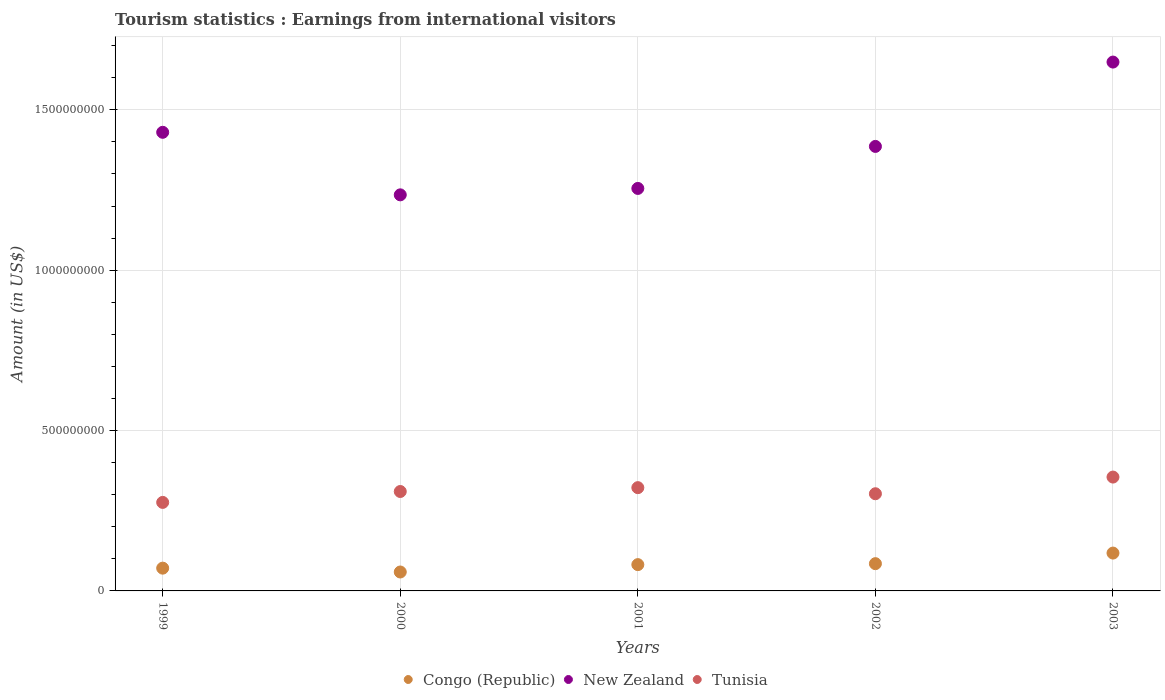Is the number of dotlines equal to the number of legend labels?
Make the answer very short. Yes. What is the earnings from international visitors in Tunisia in 2002?
Keep it short and to the point. 3.03e+08. Across all years, what is the maximum earnings from international visitors in Tunisia?
Offer a terse response. 3.55e+08. Across all years, what is the minimum earnings from international visitors in Congo (Republic)?
Your answer should be compact. 5.90e+07. In which year was the earnings from international visitors in New Zealand maximum?
Your answer should be compact. 2003. In which year was the earnings from international visitors in Tunisia minimum?
Your answer should be compact. 1999. What is the total earnings from international visitors in Congo (Republic) in the graph?
Provide a short and direct response. 4.15e+08. What is the difference between the earnings from international visitors in New Zealand in 1999 and that in 2001?
Ensure brevity in your answer.  1.75e+08. What is the difference between the earnings from international visitors in Congo (Republic) in 2003 and the earnings from international visitors in New Zealand in 2000?
Your answer should be compact. -1.12e+09. What is the average earnings from international visitors in Congo (Republic) per year?
Provide a short and direct response. 8.30e+07. In the year 2001, what is the difference between the earnings from international visitors in Congo (Republic) and earnings from international visitors in New Zealand?
Your answer should be compact. -1.17e+09. What is the ratio of the earnings from international visitors in New Zealand in 1999 to that in 2003?
Offer a terse response. 0.87. Is the difference between the earnings from international visitors in Congo (Republic) in 1999 and 2000 greater than the difference between the earnings from international visitors in New Zealand in 1999 and 2000?
Your answer should be compact. No. What is the difference between the highest and the second highest earnings from international visitors in New Zealand?
Provide a short and direct response. 2.19e+08. What is the difference between the highest and the lowest earnings from international visitors in New Zealand?
Your answer should be very brief. 4.14e+08. How many years are there in the graph?
Ensure brevity in your answer.  5. What is the difference between two consecutive major ticks on the Y-axis?
Give a very brief answer. 5.00e+08. Does the graph contain any zero values?
Give a very brief answer. No. Does the graph contain grids?
Your response must be concise. Yes. Where does the legend appear in the graph?
Keep it short and to the point. Bottom center. What is the title of the graph?
Make the answer very short. Tourism statistics : Earnings from international visitors. Does "Macao" appear as one of the legend labels in the graph?
Make the answer very short. No. What is the Amount (in US$) of Congo (Republic) in 1999?
Your response must be concise. 7.10e+07. What is the Amount (in US$) in New Zealand in 1999?
Provide a short and direct response. 1.43e+09. What is the Amount (in US$) of Tunisia in 1999?
Your answer should be compact. 2.76e+08. What is the Amount (in US$) in Congo (Republic) in 2000?
Offer a terse response. 5.90e+07. What is the Amount (in US$) in New Zealand in 2000?
Offer a very short reply. 1.24e+09. What is the Amount (in US$) in Tunisia in 2000?
Keep it short and to the point. 3.10e+08. What is the Amount (in US$) in Congo (Republic) in 2001?
Your answer should be very brief. 8.20e+07. What is the Amount (in US$) of New Zealand in 2001?
Your answer should be very brief. 1.26e+09. What is the Amount (in US$) in Tunisia in 2001?
Provide a succinct answer. 3.22e+08. What is the Amount (in US$) in Congo (Republic) in 2002?
Your answer should be very brief. 8.50e+07. What is the Amount (in US$) of New Zealand in 2002?
Offer a very short reply. 1.39e+09. What is the Amount (in US$) in Tunisia in 2002?
Give a very brief answer. 3.03e+08. What is the Amount (in US$) in Congo (Republic) in 2003?
Your answer should be very brief. 1.18e+08. What is the Amount (in US$) of New Zealand in 2003?
Ensure brevity in your answer.  1.65e+09. What is the Amount (in US$) in Tunisia in 2003?
Offer a very short reply. 3.55e+08. Across all years, what is the maximum Amount (in US$) in Congo (Republic)?
Your answer should be compact. 1.18e+08. Across all years, what is the maximum Amount (in US$) in New Zealand?
Your answer should be very brief. 1.65e+09. Across all years, what is the maximum Amount (in US$) in Tunisia?
Your answer should be compact. 3.55e+08. Across all years, what is the minimum Amount (in US$) of Congo (Republic)?
Give a very brief answer. 5.90e+07. Across all years, what is the minimum Amount (in US$) in New Zealand?
Ensure brevity in your answer.  1.24e+09. Across all years, what is the minimum Amount (in US$) in Tunisia?
Provide a succinct answer. 2.76e+08. What is the total Amount (in US$) of Congo (Republic) in the graph?
Keep it short and to the point. 4.15e+08. What is the total Amount (in US$) of New Zealand in the graph?
Your answer should be very brief. 6.96e+09. What is the total Amount (in US$) in Tunisia in the graph?
Offer a terse response. 1.57e+09. What is the difference between the Amount (in US$) of Congo (Republic) in 1999 and that in 2000?
Offer a terse response. 1.20e+07. What is the difference between the Amount (in US$) in New Zealand in 1999 and that in 2000?
Offer a terse response. 1.95e+08. What is the difference between the Amount (in US$) of Tunisia in 1999 and that in 2000?
Provide a short and direct response. -3.40e+07. What is the difference between the Amount (in US$) of Congo (Republic) in 1999 and that in 2001?
Your answer should be very brief. -1.10e+07. What is the difference between the Amount (in US$) in New Zealand in 1999 and that in 2001?
Offer a very short reply. 1.75e+08. What is the difference between the Amount (in US$) in Tunisia in 1999 and that in 2001?
Keep it short and to the point. -4.60e+07. What is the difference between the Amount (in US$) in Congo (Republic) in 1999 and that in 2002?
Keep it short and to the point. -1.40e+07. What is the difference between the Amount (in US$) of New Zealand in 1999 and that in 2002?
Your answer should be very brief. 4.40e+07. What is the difference between the Amount (in US$) in Tunisia in 1999 and that in 2002?
Provide a succinct answer. -2.70e+07. What is the difference between the Amount (in US$) in Congo (Republic) in 1999 and that in 2003?
Your answer should be compact. -4.70e+07. What is the difference between the Amount (in US$) in New Zealand in 1999 and that in 2003?
Keep it short and to the point. -2.19e+08. What is the difference between the Amount (in US$) of Tunisia in 1999 and that in 2003?
Your answer should be very brief. -7.90e+07. What is the difference between the Amount (in US$) of Congo (Republic) in 2000 and that in 2001?
Keep it short and to the point. -2.30e+07. What is the difference between the Amount (in US$) in New Zealand in 2000 and that in 2001?
Give a very brief answer. -2.00e+07. What is the difference between the Amount (in US$) in Tunisia in 2000 and that in 2001?
Offer a terse response. -1.20e+07. What is the difference between the Amount (in US$) of Congo (Republic) in 2000 and that in 2002?
Offer a terse response. -2.60e+07. What is the difference between the Amount (in US$) in New Zealand in 2000 and that in 2002?
Your answer should be compact. -1.51e+08. What is the difference between the Amount (in US$) in Congo (Republic) in 2000 and that in 2003?
Provide a short and direct response. -5.90e+07. What is the difference between the Amount (in US$) in New Zealand in 2000 and that in 2003?
Ensure brevity in your answer.  -4.14e+08. What is the difference between the Amount (in US$) in Tunisia in 2000 and that in 2003?
Offer a terse response. -4.50e+07. What is the difference between the Amount (in US$) in New Zealand in 2001 and that in 2002?
Ensure brevity in your answer.  -1.31e+08. What is the difference between the Amount (in US$) of Tunisia in 2001 and that in 2002?
Ensure brevity in your answer.  1.90e+07. What is the difference between the Amount (in US$) of Congo (Republic) in 2001 and that in 2003?
Give a very brief answer. -3.60e+07. What is the difference between the Amount (in US$) of New Zealand in 2001 and that in 2003?
Provide a succinct answer. -3.94e+08. What is the difference between the Amount (in US$) of Tunisia in 2001 and that in 2003?
Make the answer very short. -3.30e+07. What is the difference between the Amount (in US$) in Congo (Republic) in 2002 and that in 2003?
Give a very brief answer. -3.30e+07. What is the difference between the Amount (in US$) of New Zealand in 2002 and that in 2003?
Make the answer very short. -2.63e+08. What is the difference between the Amount (in US$) of Tunisia in 2002 and that in 2003?
Offer a very short reply. -5.20e+07. What is the difference between the Amount (in US$) in Congo (Republic) in 1999 and the Amount (in US$) in New Zealand in 2000?
Provide a succinct answer. -1.16e+09. What is the difference between the Amount (in US$) in Congo (Republic) in 1999 and the Amount (in US$) in Tunisia in 2000?
Give a very brief answer. -2.39e+08. What is the difference between the Amount (in US$) of New Zealand in 1999 and the Amount (in US$) of Tunisia in 2000?
Make the answer very short. 1.12e+09. What is the difference between the Amount (in US$) in Congo (Republic) in 1999 and the Amount (in US$) in New Zealand in 2001?
Give a very brief answer. -1.18e+09. What is the difference between the Amount (in US$) in Congo (Republic) in 1999 and the Amount (in US$) in Tunisia in 2001?
Provide a short and direct response. -2.51e+08. What is the difference between the Amount (in US$) in New Zealand in 1999 and the Amount (in US$) in Tunisia in 2001?
Ensure brevity in your answer.  1.11e+09. What is the difference between the Amount (in US$) in Congo (Republic) in 1999 and the Amount (in US$) in New Zealand in 2002?
Your answer should be compact. -1.32e+09. What is the difference between the Amount (in US$) in Congo (Republic) in 1999 and the Amount (in US$) in Tunisia in 2002?
Your response must be concise. -2.32e+08. What is the difference between the Amount (in US$) of New Zealand in 1999 and the Amount (in US$) of Tunisia in 2002?
Your response must be concise. 1.13e+09. What is the difference between the Amount (in US$) of Congo (Republic) in 1999 and the Amount (in US$) of New Zealand in 2003?
Keep it short and to the point. -1.58e+09. What is the difference between the Amount (in US$) of Congo (Republic) in 1999 and the Amount (in US$) of Tunisia in 2003?
Your answer should be very brief. -2.84e+08. What is the difference between the Amount (in US$) of New Zealand in 1999 and the Amount (in US$) of Tunisia in 2003?
Make the answer very short. 1.08e+09. What is the difference between the Amount (in US$) in Congo (Republic) in 2000 and the Amount (in US$) in New Zealand in 2001?
Provide a succinct answer. -1.20e+09. What is the difference between the Amount (in US$) in Congo (Republic) in 2000 and the Amount (in US$) in Tunisia in 2001?
Offer a very short reply. -2.63e+08. What is the difference between the Amount (in US$) in New Zealand in 2000 and the Amount (in US$) in Tunisia in 2001?
Offer a very short reply. 9.13e+08. What is the difference between the Amount (in US$) in Congo (Republic) in 2000 and the Amount (in US$) in New Zealand in 2002?
Ensure brevity in your answer.  -1.33e+09. What is the difference between the Amount (in US$) of Congo (Republic) in 2000 and the Amount (in US$) of Tunisia in 2002?
Offer a terse response. -2.44e+08. What is the difference between the Amount (in US$) of New Zealand in 2000 and the Amount (in US$) of Tunisia in 2002?
Make the answer very short. 9.32e+08. What is the difference between the Amount (in US$) of Congo (Republic) in 2000 and the Amount (in US$) of New Zealand in 2003?
Provide a succinct answer. -1.59e+09. What is the difference between the Amount (in US$) in Congo (Republic) in 2000 and the Amount (in US$) in Tunisia in 2003?
Your response must be concise. -2.96e+08. What is the difference between the Amount (in US$) in New Zealand in 2000 and the Amount (in US$) in Tunisia in 2003?
Your response must be concise. 8.80e+08. What is the difference between the Amount (in US$) in Congo (Republic) in 2001 and the Amount (in US$) in New Zealand in 2002?
Offer a very short reply. -1.30e+09. What is the difference between the Amount (in US$) of Congo (Republic) in 2001 and the Amount (in US$) of Tunisia in 2002?
Keep it short and to the point. -2.21e+08. What is the difference between the Amount (in US$) in New Zealand in 2001 and the Amount (in US$) in Tunisia in 2002?
Your answer should be compact. 9.52e+08. What is the difference between the Amount (in US$) in Congo (Republic) in 2001 and the Amount (in US$) in New Zealand in 2003?
Provide a short and direct response. -1.57e+09. What is the difference between the Amount (in US$) in Congo (Republic) in 2001 and the Amount (in US$) in Tunisia in 2003?
Make the answer very short. -2.73e+08. What is the difference between the Amount (in US$) in New Zealand in 2001 and the Amount (in US$) in Tunisia in 2003?
Offer a very short reply. 9.00e+08. What is the difference between the Amount (in US$) in Congo (Republic) in 2002 and the Amount (in US$) in New Zealand in 2003?
Offer a very short reply. -1.56e+09. What is the difference between the Amount (in US$) in Congo (Republic) in 2002 and the Amount (in US$) in Tunisia in 2003?
Provide a short and direct response. -2.70e+08. What is the difference between the Amount (in US$) in New Zealand in 2002 and the Amount (in US$) in Tunisia in 2003?
Provide a short and direct response. 1.03e+09. What is the average Amount (in US$) of Congo (Republic) per year?
Keep it short and to the point. 8.30e+07. What is the average Amount (in US$) of New Zealand per year?
Provide a succinct answer. 1.39e+09. What is the average Amount (in US$) in Tunisia per year?
Keep it short and to the point. 3.13e+08. In the year 1999, what is the difference between the Amount (in US$) of Congo (Republic) and Amount (in US$) of New Zealand?
Provide a short and direct response. -1.36e+09. In the year 1999, what is the difference between the Amount (in US$) of Congo (Republic) and Amount (in US$) of Tunisia?
Your response must be concise. -2.05e+08. In the year 1999, what is the difference between the Amount (in US$) of New Zealand and Amount (in US$) of Tunisia?
Give a very brief answer. 1.15e+09. In the year 2000, what is the difference between the Amount (in US$) of Congo (Republic) and Amount (in US$) of New Zealand?
Make the answer very short. -1.18e+09. In the year 2000, what is the difference between the Amount (in US$) of Congo (Republic) and Amount (in US$) of Tunisia?
Provide a succinct answer. -2.51e+08. In the year 2000, what is the difference between the Amount (in US$) of New Zealand and Amount (in US$) of Tunisia?
Ensure brevity in your answer.  9.25e+08. In the year 2001, what is the difference between the Amount (in US$) of Congo (Republic) and Amount (in US$) of New Zealand?
Your answer should be very brief. -1.17e+09. In the year 2001, what is the difference between the Amount (in US$) in Congo (Republic) and Amount (in US$) in Tunisia?
Offer a terse response. -2.40e+08. In the year 2001, what is the difference between the Amount (in US$) in New Zealand and Amount (in US$) in Tunisia?
Provide a succinct answer. 9.33e+08. In the year 2002, what is the difference between the Amount (in US$) in Congo (Republic) and Amount (in US$) in New Zealand?
Give a very brief answer. -1.30e+09. In the year 2002, what is the difference between the Amount (in US$) of Congo (Republic) and Amount (in US$) of Tunisia?
Make the answer very short. -2.18e+08. In the year 2002, what is the difference between the Amount (in US$) of New Zealand and Amount (in US$) of Tunisia?
Offer a terse response. 1.08e+09. In the year 2003, what is the difference between the Amount (in US$) of Congo (Republic) and Amount (in US$) of New Zealand?
Ensure brevity in your answer.  -1.53e+09. In the year 2003, what is the difference between the Amount (in US$) of Congo (Republic) and Amount (in US$) of Tunisia?
Your response must be concise. -2.37e+08. In the year 2003, what is the difference between the Amount (in US$) of New Zealand and Amount (in US$) of Tunisia?
Offer a terse response. 1.29e+09. What is the ratio of the Amount (in US$) of Congo (Republic) in 1999 to that in 2000?
Offer a very short reply. 1.2. What is the ratio of the Amount (in US$) in New Zealand in 1999 to that in 2000?
Your answer should be compact. 1.16. What is the ratio of the Amount (in US$) in Tunisia in 1999 to that in 2000?
Offer a very short reply. 0.89. What is the ratio of the Amount (in US$) of Congo (Republic) in 1999 to that in 2001?
Provide a short and direct response. 0.87. What is the ratio of the Amount (in US$) in New Zealand in 1999 to that in 2001?
Ensure brevity in your answer.  1.14. What is the ratio of the Amount (in US$) of Congo (Republic) in 1999 to that in 2002?
Your answer should be compact. 0.84. What is the ratio of the Amount (in US$) in New Zealand in 1999 to that in 2002?
Offer a terse response. 1.03. What is the ratio of the Amount (in US$) in Tunisia in 1999 to that in 2002?
Give a very brief answer. 0.91. What is the ratio of the Amount (in US$) in Congo (Republic) in 1999 to that in 2003?
Offer a terse response. 0.6. What is the ratio of the Amount (in US$) in New Zealand in 1999 to that in 2003?
Keep it short and to the point. 0.87. What is the ratio of the Amount (in US$) in Tunisia in 1999 to that in 2003?
Provide a short and direct response. 0.78. What is the ratio of the Amount (in US$) of Congo (Republic) in 2000 to that in 2001?
Provide a short and direct response. 0.72. What is the ratio of the Amount (in US$) of New Zealand in 2000 to that in 2001?
Provide a short and direct response. 0.98. What is the ratio of the Amount (in US$) in Tunisia in 2000 to that in 2001?
Your answer should be compact. 0.96. What is the ratio of the Amount (in US$) of Congo (Republic) in 2000 to that in 2002?
Offer a very short reply. 0.69. What is the ratio of the Amount (in US$) in New Zealand in 2000 to that in 2002?
Make the answer very short. 0.89. What is the ratio of the Amount (in US$) in Tunisia in 2000 to that in 2002?
Make the answer very short. 1.02. What is the ratio of the Amount (in US$) in Congo (Republic) in 2000 to that in 2003?
Your response must be concise. 0.5. What is the ratio of the Amount (in US$) of New Zealand in 2000 to that in 2003?
Offer a very short reply. 0.75. What is the ratio of the Amount (in US$) in Tunisia in 2000 to that in 2003?
Provide a short and direct response. 0.87. What is the ratio of the Amount (in US$) in Congo (Republic) in 2001 to that in 2002?
Provide a short and direct response. 0.96. What is the ratio of the Amount (in US$) of New Zealand in 2001 to that in 2002?
Your answer should be very brief. 0.91. What is the ratio of the Amount (in US$) in Tunisia in 2001 to that in 2002?
Keep it short and to the point. 1.06. What is the ratio of the Amount (in US$) in Congo (Republic) in 2001 to that in 2003?
Provide a succinct answer. 0.69. What is the ratio of the Amount (in US$) in New Zealand in 2001 to that in 2003?
Keep it short and to the point. 0.76. What is the ratio of the Amount (in US$) in Tunisia in 2001 to that in 2003?
Ensure brevity in your answer.  0.91. What is the ratio of the Amount (in US$) in Congo (Republic) in 2002 to that in 2003?
Your response must be concise. 0.72. What is the ratio of the Amount (in US$) of New Zealand in 2002 to that in 2003?
Your answer should be very brief. 0.84. What is the ratio of the Amount (in US$) in Tunisia in 2002 to that in 2003?
Your answer should be compact. 0.85. What is the difference between the highest and the second highest Amount (in US$) of Congo (Republic)?
Offer a terse response. 3.30e+07. What is the difference between the highest and the second highest Amount (in US$) in New Zealand?
Give a very brief answer. 2.19e+08. What is the difference between the highest and the second highest Amount (in US$) in Tunisia?
Your answer should be compact. 3.30e+07. What is the difference between the highest and the lowest Amount (in US$) in Congo (Republic)?
Your answer should be very brief. 5.90e+07. What is the difference between the highest and the lowest Amount (in US$) in New Zealand?
Offer a very short reply. 4.14e+08. What is the difference between the highest and the lowest Amount (in US$) in Tunisia?
Keep it short and to the point. 7.90e+07. 